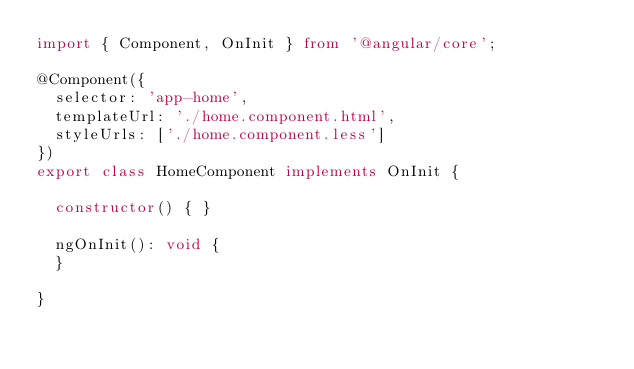Convert code to text. <code><loc_0><loc_0><loc_500><loc_500><_TypeScript_>import { Component, OnInit } from '@angular/core';

@Component({
  selector: 'app-home',
  templateUrl: './home.component.html',
  styleUrls: ['./home.component.less']
})
export class HomeComponent implements OnInit {

  constructor() { }

  ngOnInit(): void {
  }

}
</code> 